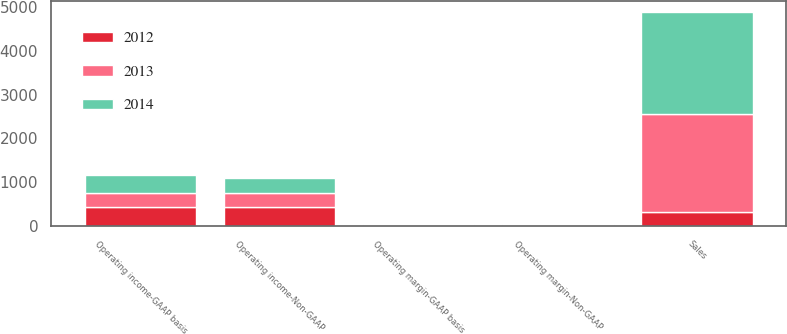Convert chart. <chart><loc_0><loc_0><loc_500><loc_500><stacked_bar_chart><ecel><fcel>Sales<fcel>Operating income-GAAP basis<fcel>Operating margin-GAAP basis<fcel>Operating income-Non-GAAP<fcel>Operating margin-Non-GAAP<nl><fcel>2012<fcel>321.3<fcel>425.3<fcel>17.4<fcel>425.3<fcel>17.4<nl><fcel>2013<fcel>2243.4<fcel>321.3<fcel>14.3<fcel>321.3<fcel>14.3<nl><fcel>2014<fcel>2322.5<fcel>425.6<fcel>18.3<fcel>339.7<fcel>14.6<nl></chart> 